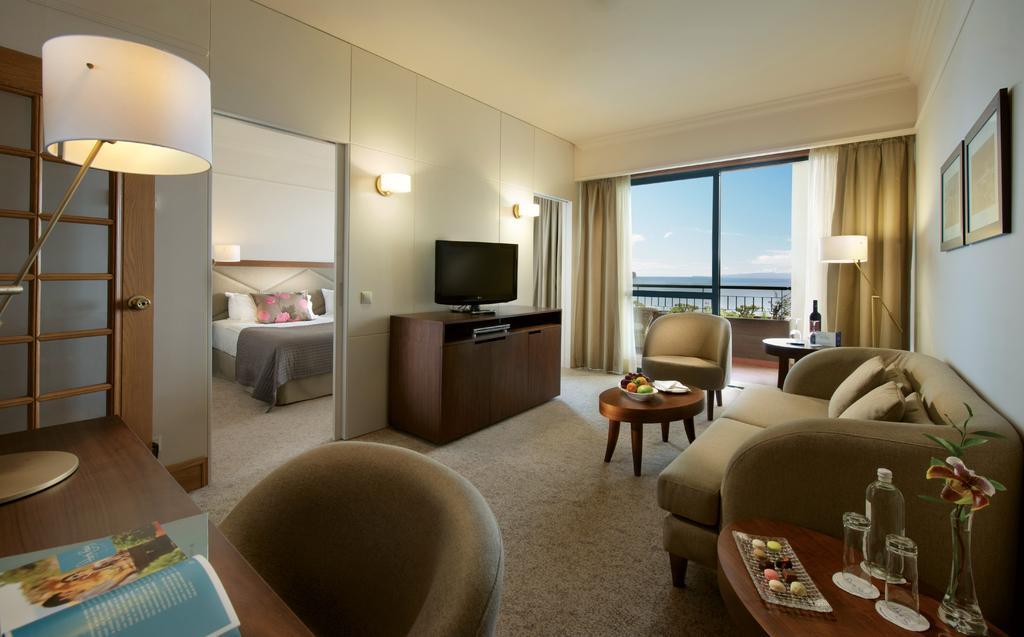Please provide a concise description of this image. On the left we can see book and lamp on the table. On the right there is a table,on table we can see glasses,bottle,flower vase. Bedside table there is a couch,in the center there is a monitor,tables,chairs,bed,blanket,pillows etc. In the background we can see curtain,wall,tree,sky with clouds. 